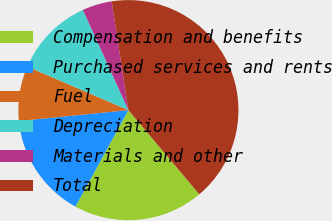Convert chart. <chart><loc_0><loc_0><loc_500><loc_500><pie_chart><fcel>Compensation and benefits<fcel>Purchased services and rents<fcel>Fuel<fcel>Depreciation<fcel>Materials and other<fcel>Total<nl><fcel>19.13%<fcel>15.44%<fcel>8.05%<fcel>11.74%<fcel>4.35%<fcel>41.29%<nl></chart> 